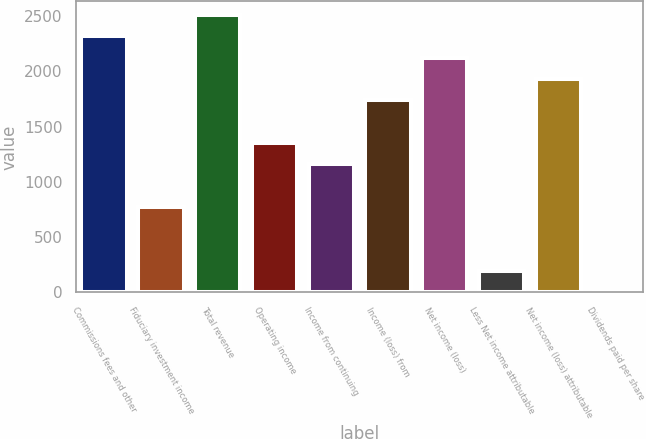<chart> <loc_0><loc_0><loc_500><loc_500><bar_chart><fcel>Commissions fees and other<fcel>Fiduciary investment income<fcel>Total revenue<fcel>Operating income<fcel>Income from continuing<fcel>Income (loss) from<fcel>Net income (loss)<fcel>Less Net income attributable<fcel>Net income (loss) attributable<fcel>Dividends paid per share<nl><fcel>2317.2<fcel>772.5<fcel>2510.28<fcel>1351.76<fcel>1158.67<fcel>1737.93<fcel>2124.11<fcel>193.24<fcel>1931.02<fcel>0.15<nl></chart> 